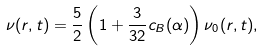Convert formula to latex. <formula><loc_0><loc_0><loc_500><loc_500>\nu ( { r } , t ) = \frac { 5 } { 2 } \left ( 1 + \frac { 3 } { 3 2 } c _ { B } ( \alpha ) \right ) \nu _ { 0 } ( { r } , t ) ,</formula> 